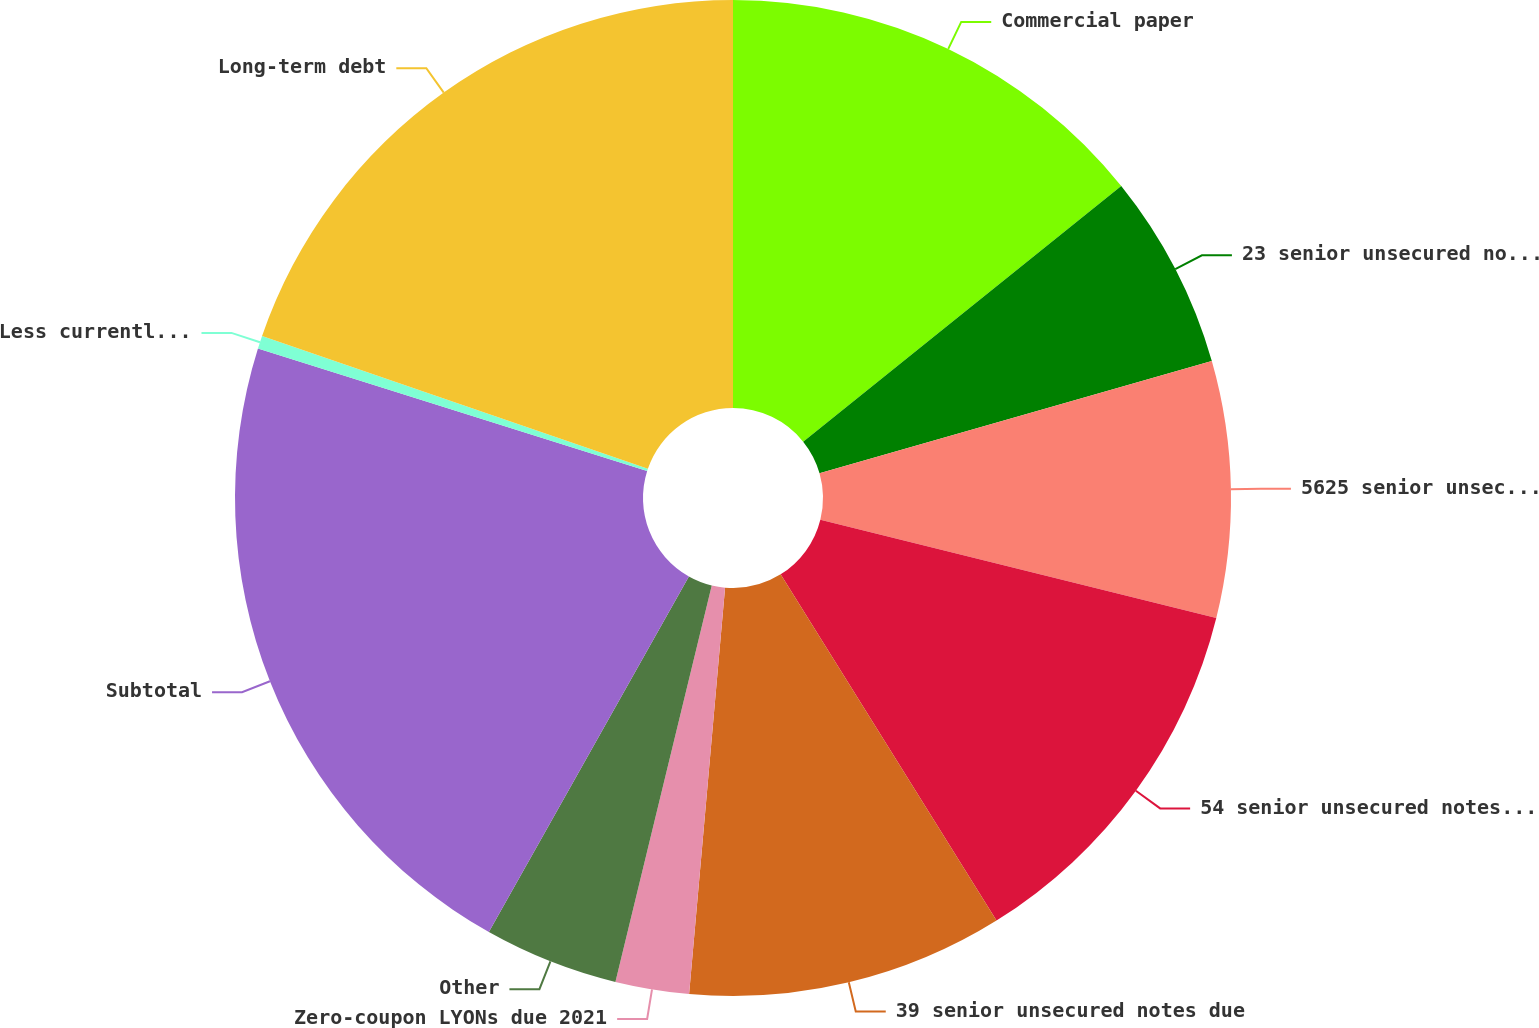<chart> <loc_0><loc_0><loc_500><loc_500><pie_chart><fcel>Commercial paper<fcel>23 senior unsecured notes due<fcel>5625 senior unsecured notes<fcel>54 senior unsecured notes due<fcel>39 senior unsecured notes due<fcel>Zero-coupon LYONs due 2021<fcel>Other<fcel>Subtotal<fcel>Less currently payable<fcel>Long-term debt<nl><fcel>14.23%<fcel>6.34%<fcel>8.31%<fcel>12.25%<fcel>10.28%<fcel>2.39%<fcel>4.36%<fcel>21.7%<fcel>0.42%<fcel>19.73%<nl></chart> 